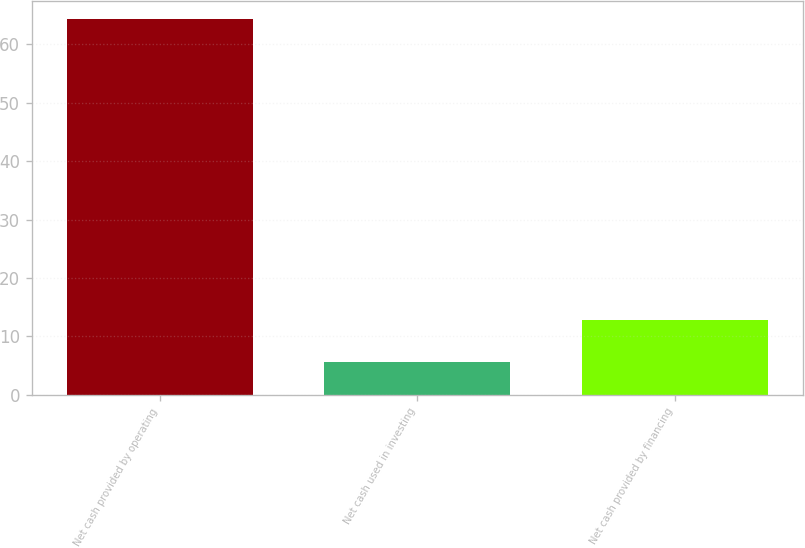<chart> <loc_0><loc_0><loc_500><loc_500><bar_chart><fcel>Net cash provided by operating<fcel>Net cash used in investing<fcel>Net cash provided by financing<nl><fcel>64.3<fcel>5.7<fcel>12.8<nl></chart> 